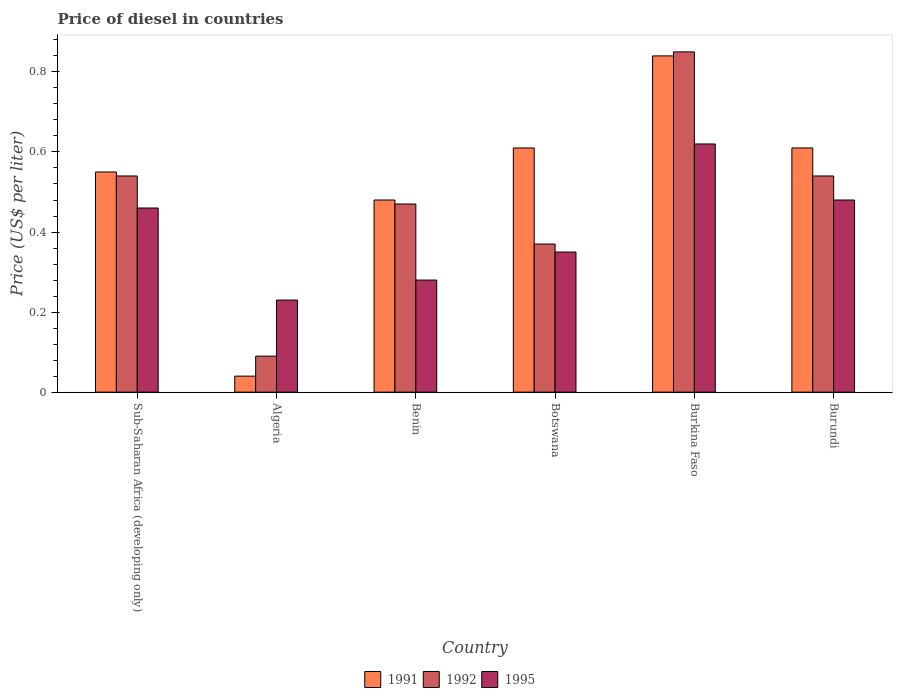How many different coloured bars are there?
Your response must be concise. 3. How many groups of bars are there?
Keep it short and to the point. 6. How many bars are there on the 6th tick from the left?
Keep it short and to the point. 3. How many bars are there on the 1st tick from the right?
Provide a short and direct response. 3. What is the label of the 5th group of bars from the left?
Give a very brief answer. Burkina Faso. In how many cases, is the number of bars for a given country not equal to the number of legend labels?
Your answer should be compact. 0. What is the price of diesel in 1992 in Sub-Saharan Africa (developing only)?
Provide a short and direct response. 0.54. In which country was the price of diesel in 1992 maximum?
Give a very brief answer. Burkina Faso. In which country was the price of diesel in 1992 minimum?
Ensure brevity in your answer.  Algeria. What is the total price of diesel in 1995 in the graph?
Provide a short and direct response. 2.42. What is the difference between the price of diesel in 1991 in Algeria and that in Burkina Faso?
Your answer should be compact. -0.8. What is the difference between the price of diesel in 1991 in Burkina Faso and the price of diesel in 1992 in Sub-Saharan Africa (developing only)?
Keep it short and to the point. 0.3. What is the average price of diesel in 1992 per country?
Your response must be concise. 0.48. What is the difference between the price of diesel of/in 1992 and price of diesel of/in 1991 in Benin?
Give a very brief answer. -0.01. What is the difference between the highest and the second highest price of diesel in 1995?
Ensure brevity in your answer.  0.14. What is the difference between the highest and the lowest price of diesel in 1992?
Give a very brief answer. 0.76. In how many countries, is the price of diesel in 1991 greater than the average price of diesel in 1991 taken over all countries?
Offer a very short reply. 4. Are the values on the major ticks of Y-axis written in scientific E-notation?
Your response must be concise. No. Does the graph contain any zero values?
Offer a very short reply. No. Where does the legend appear in the graph?
Offer a very short reply. Bottom center. How are the legend labels stacked?
Give a very brief answer. Horizontal. What is the title of the graph?
Your answer should be very brief. Price of diesel in countries. Does "1963" appear as one of the legend labels in the graph?
Your answer should be very brief. No. What is the label or title of the Y-axis?
Offer a terse response. Price (US$ per liter). What is the Price (US$ per liter) of 1991 in Sub-Saharan Africa (developing only)?
Provide a succinct answer. 0.55. What is the Price (US$ per liter) of 1992 in Sub-Saharan Africa (developing only)?
Your answer should be compact. 0.54. What is the Price (US$ per liter) of 1995 in Sub-Saharan Africa (developing only)?
Give a very brief answer. 0.46. What is the Price (US$ per liter) in 1991 in Algeria?
Keep it short and to the point. 0.04. What is the Price (US$ per liter) of 1992 in Algeria?
Provide a short and direct response. 0.09. What is the Price (US$ per liter) of 1995 in Algeria?
Provide a short and direct response. 0.23. What is the Price (US$ per liter) in 1991 in Benin?
Keep it short and to the point. 0.48. What is the Price (US$ per liter) of 1992 in Benin?
Your answer should be very brief. 0.47. What is the Price (US$ per liter) of 1995 in Benin?
Offer a terse response. 0.28. What is the Price (US$ per liter) of 1991 in Botswana?
Your answer should be very brief. 0.61. What is the Price (US$ per liter) in 1992 in Botswana?
Make the answer very short. 0.37. What is the Price (US$ per liter) in 1991 in Burkina Faso?
Offer a terse response. 0.84. What is the Price (US$ per liter) of 1995 in Burkina Faso?
Provide a succinct answer. 0.62. What is the Price (US$ per liter) in 1991 in Burundi?
Offer a terse response. 0.61. What is the Price (US$ per liter) in 1992 in Burundi?
Offer a terse response. 0.54. What is the Price (US$ per liter) in 1995 in Burundi?
Give a very brief answer. 0.48. Across all countries, what is the maximum Price (US$ per liter) of 1991?
Give a very brief answer. 0.84. Across all countries, what is the maximum Price (US$ per liter) in 1995?
Offer a terse response. 0.62. Across all countries, what is the minimum Price (US$ per liter) in 1992?
Keep it short and to the point. 0.09. Across all countries, what is the minimum Price (US$ per liter) of 1995?
Keep it short and to the point. 0.23. What is the total Price (US$ per liter) of 1991 in the graph?
Keep it short and to the point. 3.13. What is the total Price (US$ per liter) of 1992 in the graph?
Give a very brief answer. 2.86. What is the total Price (US$ per liter) of 1995 in the graph?
Offer a terse response. 2.42. What is the difference between the Price (US$ per liter) in 1991 in Sub-Saharan Africa (developing only) and that in Algeria?
Offer a very short reply. 0.51. What is the difference between the Price (US$ per liter) in 1992 in Sub-Saharan Africa (developing only) and that in Algeria?
Provide a short and direct response. 0.45. What is the difference between the Price (US$ per liter) in 1995 in Sub-Saharan Africa (developing only) and that in Algeria?
Give a very brief answer. 0.23. What is the difference between the Price (US$ per liter) of 1991 in Sub-Saharan Africa (developing only) and that in Benin?
Provide a short and direct response. 0.07. What is the difference between the Price (US$ per liter) in 1992 in Sub-Saharan Africa (developing only) and that in Benin?
Provide a succinct answer. 0.07. What is the difference between the Price (US$ per liter) of 1995 in Sub-Saharan Africa (developing only) and that in Benin?
Ensure brevity in your answer.  0.18. What is the difference between the Price (US$ per liter) in 1991 in Sub-Saharan Africa (developing only) and that in Botswana?
Offer a terse response. -0.06. What is the difference between the Price (US$ per liter) of 1992 in Sub-Saharan Africa (developing only) and that in Botswana?
Provide a succinct answer. 0.17. What is the difference between the Price (US$ per liter) in 1995 in Sub-Saharan Africa (developing only) and that in Botswana?
Give a very brief answer. 0.11. What is the difference between the Price (US$ per liter) of 1991 in Sub-Saharan Africa (developing only) and that in Burkina Faso?
Offer a very short reply. -0.29. What is the difference between the Price (US$ per liter) of 1992 in Sub-Saharan Africa (developing only) and that in Burkina Faso?
Offer a very short reply. -0.31. What is the difference between the Price (US$ per liter) of 1995 in Sub-Saharan Africa (developing only) and that in Burkina Faso?
Your answer should be compact. -0.16. What is the difference between the Price (US$ per liter) of 1991 in Sub-Saharan Africa (developing only) and that in Burundi?
Ensure brevity in your answer.  -0.06. What is the difference between the Price (US$ per liter) in 1995 in Sub-Saharan Africa (developing only) and that in Burundi?
Your answer should be very brief. -0.02. What is the difference between the Price (US$ per liter) in 1991 in Algeria and that in Benin?
Make the answer very short. -0.44. What is the difference between the Price (US$ per liter) in 1992 in Algeria and that in Benin?
Make the answer very short. -0.38. What is the difference between the Price (US$ per liter) of 1991 in Algeria and that in Botswana?
Your answer should be compact. -0.57. What is the difference between the Price (US$ per liter) in 1992 in Algeria and that in Botswana?
Give a very brief answer. -0.28. What is the difference between the Price (US$ per liter) of 1995 in Algeria and that in Botswana?
Ensure brevity in your answer.  -0.12. What is the difference between the Price (US$ per liter) of 1991 in Algeria and that in Burkina Faso?
Ensure brevity in your answer.  -0.8. What is the difference between the Price (US$ per liter) in 1992 in Algeria and that in Burkina Faso?
Offer a terse response. -0.76. What is the difference between the Price (US$ per liter) of 1995 in Algeria and that in Burkina Faso?
Offer a very short reply. -0.39. What is the difference between the Price (US$ per liter) of 1991 in Algeria and that in Burundi?
Provide a short and direct response. -0.57. What is the difference between the Price (US$ per liter) in 1992 in Algeria and that in Burundi?
Offer a terse response. -0.45. What is the difference between the Price (US$ per liter) in 1991 in Benin and that in Botswana?
Offer a very short reply. -0.13. What is the difference between the Price (US$ per liter) of 1992 in Benin and that in Botswana?
Your response must be concise. 0.1. What is the difference between the Price (US$ per liter) of 1995 in Benin and that in Botswana?
Provide a short and direct response. -0.07. What is the difference between the Price (US$ per liter) in 1991 in Benin and that in Burkina Faso?
Your answer should be very brief. -0.36. What is the difference between the Price (US$ per liter) in 1992 in Benin and that in Burkina Faso?
Ensure brevity in your answer.  -0.38. What is the difference between the Price (US$ per liter) of 1995 in Benin and that in Burkina Faso?
Give a very brief answer. -0.34. What is the difference between the Price (US$ per liter) in 1991 in Benin and that in Burundi?
Ensure brevity in your answer.  -0.13. What is the difference between the Price (US$ per liter) in 1992 in Benin and that in Burundi?
Provide a short and direct response. -0.07. What is the difference between the Price (US$ per liter) in 1991 in Botswana and that in Burkina Faso?
Provide a succinct answer. -0.23. What is the difference between the Price (US$ per liter) of 1992 in Botswana and that in Burkina Faso?
Make the answer very short. -0.48. What is the difference between the Price (US$ per liter) in 1995 in Botswana and that in Burkina Faso?
Your answer should be very brief. -0.27. What is the difference between the Price (US$ per liter) of 1992 in Botswana and that in Burundi?
Your response must be concise. -0.17. What is the difference between the Price (US$ per liter) of 1995 in Botswana and that in Burundi?
Your answer should be very brief. -0.13. What is the difference between the Price (US$ per liter) of 1991 in Burkina Faso and that in Burundi?
Provide a succinct answer. 0.23. What is the difference between the Price (US$ per liter) of 1992 in Burkina Faso and that in Burundi?
Make the answer very short. 0.31. What is the difference between the Price (US$ per liter) in 1995 in Burkina Faso and that in Burundi?
Make the answer very short. 0.14. What is the difference between the Price (US$ per liter) of 1991 in Sub-Saharan Africa (developing only) and the Price (US$ per liter) of 1992 in Algeria?
Offer a terse response. 0.46. What is the difference between the Price (US$ per liter) of 1991 in Sub-Saharan Africa (developing only) and the Price (US$ per liter) of 1995 in Algeria?
Provide a short and direct response. 0.32. What is the difference between the Price (US$ per liter) of 1992 in Sub-Saharan Africa (developing only) and the Price (US$ per liter) of 1995 in Algeria?
Provide a succinct answer. 0.31. What is the difference between the Price (US$ per liter) in 1991 in Sub-Saharan Africa (developing only) and the Price (US$ per liter) in 1995 in Benin?
Your response must be concise. 0.27. What is the difference between the Price (US$ per liter) of 1992 in Sub-Saharan Africa (developing only) and the Price (US$ per liter) of 1995 in Benin?
Ensure brevity in your answer.  0.26. What is the difference between the Price (US$ per liter) of 1991 in Sub-Saharan Africa (developing only) and the Price (US$ per liter) of 1992 in Botswana?
Provide a succinct answer. 0.18. What is the difference between the Price (US$ per liter) of 1991 in Sub-Saharan Africa (developing only) and the Price (US$ per liter) of 1995 in Botswana?
Your answer should be compact. 0.2. What is the difference between the Price (US$ per liter) of 1992 in Sub-Saharan Africa (developing only) and the Price (US$ per liter) of 1995 in Botswana?
Your answer should be compact. 0.19. What is the difference between the Price (US$ per liter) of 1991 in Sub-Saharan Africa (developing only) and the Price (US$ per liter) of 1995 in Burkina Faso?
Provide a short and direct response. -0.07. What is the difference between the Price (US$ per liter) in 1992 in Sub-Saharan Africa (developing only) and the Price (US$ per liter) in 1995 in Burkina Faso?
Offer a terse response. -0.08. What is the difference between the Price (US$ per liter) in 1991 in Sub-Saharan Africa (developing only) and the Price (US$ per liter) in 1992 in Burundi?
Give a very brief answer. 0.01. What is the difference between the Price (US$ per liter) of 1991 in Sub-Saharan Africa (developing only) and the Price (US$ per liter) of 1995 in Burundi?
Give a very brief answer. 0.07. What is the difference between the Price (US$ per liter) of 1992 in Sub-Saharan Africa (developing only) and the Price (US$ per liter) of 1995 in Burundi?
Offer a very short reply. 0.06. What is the difference between the Price (US$ per liter) in 1991 in Algeria and the Price (US$ per liter) in 1992 in Benin?
Provide a succinct answer. -0.43. What is the difference between the Price (US$ per liter) in 1991 in Algeria and the Price (US$ per liter) in 1995 in Benin?
Make the answer very short. -0.24. What is the difference between the Price (US$ per liter) in 1992 in Algeria and the Price (US$ per liter) in 1995 in Benin?
Make the answer very short. -0.19. What is the difference between the Price (US$ per liter) in 1991 in Algeria and the Price (US$ per liter) in 1992 in Botswana?
Provide a succinct answer. -0.33. What is the difference between the Price (US$ per liter) of 1991 in Algeria and the Price (US$ per liter) of 1995 in Botswana?
Provide a short and direct response. -0.31. What is the difference between the Price (US$ per liter) of 1992 in Algeria and the Price (US$ per liter) of 1995 in Botswana?
Offer a very short reply. -0.26. What is the difference between the Price (US$ per liter) of 1991 in Algeria and the Price (US$ per liter) of 1992 in Burkina Faso?
Provide a succinct answer. -0.81. What is the difference between the Price (US$ per liter) in 1991 in Algeria and the Price (US$ per liter) in 1995 in Burkina Faso?
Ensure brevity in your answer.  -0.58. What is the difference between the Price (US$ per liter) in 1992 in Algeria and the Price (US$ per liter) in 1995 in Burkina Faso?
Offer a terse response. -0.53. What is the difference between the Price (US$ per liter) of 1991 in Algeria and the Price (US$ per liter) of 1995 in Burundi?
Ensure brevity in your answer.  -0.44. What is the difference between the Price (US$ per liter) in 1992 in Algeria and the Price (US$ per liter) in 1995 in Burundi?
Ensure brevity in your answer.  -0.39. What is the difference between the Price (US$ per liter) in 1991 in Benin and the Price (US$ per liter) in 1992 in Botswana?
Make the answer very short. 0.11. What is the difference between the Price (US$ per liter) in 1991 in Benin and the Price (US$ per liter) in 1995 in Botswana?
Offer a terse response. 0.13. What is the difference between the Price (US$ per liter) in 1992 in Benin and the Price (US$ per liter) in 1995 in Botswana?
Keep it short and to the point. 0.12. What is the difference between the Price (US$ per liter) in 1991 in Benin and the Price (US$ per liter) in 1992 in Burkina Faso?
Your answer should be very brief. -0.37. What is the difference between the Price (US$ per liter) in 1991 in Benin and the Price (US$ per liter) in 1995 in Burkina Faso?
Give a very brief answer. -0.14. What is the difference between the Price (US$ per liter) of 1992 in Benin and the Price (US$ per liter) of 1995 in Burkina Faso?
Your answer should be very brief. -0.15. What is the difference between the Price (US$ per liter) of 1991 in Benin and the Price (US$ per liter) of 1992 in Burundi?
Give a very brief answer. -0.06. What is the difference between the Price (US$ per liter) of 1991 in Benin and the Price (US$ per liter) of 1995 in Burundi?
Your response must be concise. 0. What is the difference between the Price (US$ per liter) of 1992 in Benin and the Price (US$ per liter) of 1995 in Burundi?
Provide a short and direct response. -0.01. What is the difference between the Price (US$ per liter) of 1991 in Botswana and the Price (US$ per liter) of 1992 in Burkina Faso?
Offer a very short reply. -0.24. What is the difference between the Price (US$ per liter) in 1991 in Botswana and the Price (US$ per liter) in 1995 in Burkina Faso?
Offer a very short reply. -0.01. What is the difference between the Price (US$ per liter) in 1991 in Botswana and the Price (US$ per liter) in 1992 in Burundi?
Give a very brief answer. 0.07. What is the difference between the Price (US$ per liter) of 1991 in Botswana and the Price (US$ per liter) of 1995 in Burundi?
Your answer should be very brief. 0.13. What is the difference between the Price (US$ per liter) of 1992 in Botswana and the Price (US$ per liter) of 1995 in Burundi?
Your response must be concise. -0.11. What is the difference between the Price (US$ per liter) of 1991 in Burkina Faso and the Price (US$ per liter) of 1995 in Burundi?
Provide a short and direct response. 0.36. What is the difference between the Price (US$ per liter) of 1992 in Burkina Faso and the Price (US$ per liter) of 1995 in Burundi?
Offer a terse response. 0.37. What is the average Price (US$ per liter) in 1991 per country?
Offer a very short reply. 0.52. What is the average Price (US$ per liter) in 1992 per country?
Give a very brief answer. 0.48. What is the average Price (US$ per liter) of 1995 per country?
Provide a succinct answer. 0.4. What is the difference between the Price (US$ per liter) of 1991 and Price (US$ per liter) of 1992 in Sub-Saharan Africa (developing only)?
Offer a terse response. 0.01. What is the difference between the Price (US$ per liter) in 1991 and Price (US$ per liter) in 1995 in Sub-Saharan Africa (developing only)?
Ensure brevity in your answer.  0.09. What is the difference between the Price (US$ per liter) of 1992 and Price (US$ per liter) of 1995 in Sub-Saharan Africa (developing only)?
Provide a short and direct response. 0.08. What is the difference between the Price (US$ per liter) of 1991 and Price (US$ per liter) of 1995 in Algeria?
Your response must be concise. -0.19. What is the difference between the Price (US$ per liter) of 1992 and Price (US$ per liter) of 1995 in Algeria?
Offer a very short reply. -0.14. What is the difference between the Price (US$ per liter) in 1991 and Price (US$ per liter) in 1992 in Benin?
Offer a terse response. 0.01. What is the difference between the Price (US$ per liter) of 1991 and Price (US$ per liter) of 1995 in Benin?
Your answer should be compact. 0.2. What is the difference between the Price (US$ per liter) in 1992 and Price (US$ per liter) in 1995 in Benin?
Your response must be concise. 0.19. What is the difference between the Price (US$ per liter) of 1991 and Price (US$ per liter) of 1992 in Botswana?
Your answer should be very brief. 0.24. What is the difference between the Price (US$ per liter) in 1991 and Price (US$ per liter) in 1995 in Botswana?
Your answer should be compact. 0.26. What is the difference between the Price (US$ per liter) of 1992 and Price (US$ per liter) of 1995 in Botswana?
Ensure brevity in your answer.  0.02. What is the difference between the Price (US$ per liter) in 1991 and Price (US$ per liter) in 1992 in Burkina Faso?
Provide a short and direct response. -0.01. What is the difference between the Price (US$ per liter) of 1991 and Price (US$ per liter) of 1995 in Burkina Faso?
Offer a terse response. 0.22. What is the difference between the Price (US$ per liter) in 1992 and Price (US$ per liter) in 1995 in Burkina Faso?
Make the answer very short. 0.23. What is the difference between the Price (US$ per liter) in 1991 and Price (US$ per liter) in 1992 in Burundi?
Your answer should be compact. 0.07. What is the difference between the Price (US$ per liter) in 1991 and Price (US$ per liter) in 1995 in Burundi?
Provide a succinct answer. 0.13. What is the difference between the Price (US$ per liter) of 1992 and Price (US$ per liter) of 1995 in Burundi?
Your answer should be very brief. 0.06. What is the ratio of the Price (US$ per liter) in 1991 in Sub-Saharan Africa (developing only) to that in Algeria?
Your answer should be compact. 13.75. What is the ratio of the Price (US$ per liter) of 1992 in Sub-Saharan Africa (developing only) to that in Algeria?
Ensure brevity in your answer.  6. What is the ratio of the Price (US$ per liter) in 1991 in Sub-Saharan Africa (developing only) to that in Benin?
Offer a very short reply. 1.15. What is the ratio of the Price (US$ per liter) in 1992 in Sub-Saharan Africa (developing only) to that in Benin?
Your answer should be very brief. 1.15. What is the ratio of the Price (US$ per liter) of 1995 in Sub-Saharan Africa (developing only) to that in Benin?
Your answer should be very brief. 1.64. What is the ratio of the Price (US$ per liter) in 1991 in Sub-Saharan Africa (developing only) to that in Botswana?
Your answer should be compact. 0.9. What is the ratio of the Price (US$ per liter) in 1992 in Sub-Saharan Africa (developing only) to that in Botswana?
Your response must be concise. 1.46. What is the ratio of the Price (US$ per liter) in 1995 in Sub-Saharan Africa (developing only) to that in Botswana?
Give a very brief answer. 1.31. What is the ratio of the Price (US$ per liter) in 1991 in Sub-Saharan Africa (developing only) to that in Burkina Faso?
Ensure brevity in your answer.  0.65. What is the ratio of the Price (US$ per liter) of 1992 in Sub-Saharan Africa (developing only) to that in Burkina Faso?
Ensure brevity in your answer.  0.64. What is the ratio of the Price (US$ per liter) in 1995 in Sub-Saharan Africa (developing only) to that in Burkina Faso?
Provide a succinct answer. 0.74. What is the ratio of the Price (US$ per liter) in 1991 in Sub-Saharan Africa (developing only) to that in Burundi?
Your response must be concise. 0.9. What is the ratio of the Price (US$ per liter) in 1992 in Sub-Saharan Africa (developing only) to that in Burundi?
Ensure brevity in your answer.  1. What is the ratio of the Price (US$ per liter) in 1991 in Algeria to that in Benin?
Give a very brief answer. 0.08. What is the ratio of the Price (US$ per liter) of 1992 in Algeria to that in Benin?
Make the answer very short. 0.19. What is the ratio of the Price (US$ per liter) in 1995 in Algeria to that in Benin?
Keep it short and to the point. 0.82. What is the ratio of the Price (US$ per liter) in 1991 in Algeria to that in Botswana?
Offer a terse response. 0.07. What is the ratio of the Price (US$ per liter) in 1992 in Algeria to that in Botswana?
Ensure brevity in your answer.  0.24. What is the ratio of the Price (US$ per liter) in 1995 in Algeria to that in Botswana?
Provide a short and direct response. 0.66. What is the ratio of the Price (US$ per liter) of 1991 in Algeria to that in Burkina Faso?
Make the answer very short. 0.05. What is the ratio of the Price (US$ per liter) in 1992 in Algeria to that in Burkina Faso?
Keep it short and to the point. 0.11. What is the ratio of the Price (US$ per liter) in 1995 in Algeria to that in Burkina Faso?
Make the answer very short. 0.37. What is the ratio of the Price (US$ per liter) in 1991 in Algeria to that in Burundi?
Make the answer very short. 0.07. What is the ratio of the Price (US$ per liter) in 1992 in Algeria to that in Burundi?
Offer a very short reply. 0.17. What is the ratio of the Price (US$ per liter) of 1995 in Algeria to that in Burundi?
Make the answer very short. 0.48. What is the ratio of the Price (US$ per liter) of 1991 in Benin to that in Botswana?
Ensure brevity in your answer.  0.79. What is the ratio of the Price (US$ per liter) of 1992 in Benin to that in Botswana?
Give a very brief answer. 1.27. What is the ratio of the Price (US$ per liter) of 1995 in Benin to that in Botswana?
Offer a very short reply. 0.8. What is the ratio of the Price (US$ per liter) in 1991 in Benin to that in Burkina Faso?
Ensure brevity in your answer.  0.57. What is the ratio of the Price (US$ per liter) of 1992 in Benin to that in Burkina Faso?
Your answer should be compact. 0.55. What is the ratio of the Price (US$ per liter) in 1995 in Benin to that in Burkina Faso?
Your answer should be very brief. 0.45. What is the ratio of the Price (US$ per liter) in 1991 in Benin to that in Burundi?
Your answer should be compact. 0.79. What is the ratio of the Price (US$ per liter) of 1992 in Benin to that in Burundi?
Provide a short and direct response. 0.87. What is the ratio of the Price (US$ per liter) in 1995 in Benin to that in Burundi?
Your answer should be very brief. 0.58. What is the ratio of the Price (US$ per liter) of 1991 in Botswana to that in Burkina Faso?
Give a very brief answer. 0.73. What is the ratio of the Price (US$ per liter) in 1992 in Botswana to that in Burkina Faso?
Your response must be concise. 0.44. What is the ratio of the Price (US$ per liter) in 1995 in Botswana to that in Burkina Faso?
Offer a very short reply. 0.56. What is the ratio of the Price (US$ per liter) of 1991 in Botswana to that in Burundi?
Make the answer very short. 1. What is the ratio of the Price (US$ per liter) of 1992 in Botswana to that in Burundi?
Offer a terse response. 0.69. What is the ratio of the Price (US$ per liter) in 1995 in Botswana to that in Burundi?
Keep it short and to the point. 0.73. What is the ratio of the Price (US$ per liter) in 1991 in Burkina Faso to that in Burundi?
Provide a short and direct response. 1.38. What is the ratio of the Price (US$ per liter) of 1992 in Burkina Faso to that in Burundi?
Ensure brevity in your answer.  1.57. What is the ratio of the Price (US$ per liter) of 1995 in Burkina Faso to that in Burundi?
Offer a very short reply. 1.29. What is the difference between the highest and the second highest Price (US$ per liter) in 1991?
Keep it short and to the point. 0.23. What is the difference between the highest and the second highest Price (US$ per liter) in 1992?
Keep it short and to the point. 0.31. What is the difference between the highest and the second highest Price (US$ per liter) of 1995?
Offer a terse response. 0.14. What is the difference between the highest and the lowest Price (US$ per liter) of 1992?
Keep it short and to the point. 0.76. What is the difference between the highest and the lowest Price (US$ per liter) in 1995?
Offer a very short reply. 0.39. 